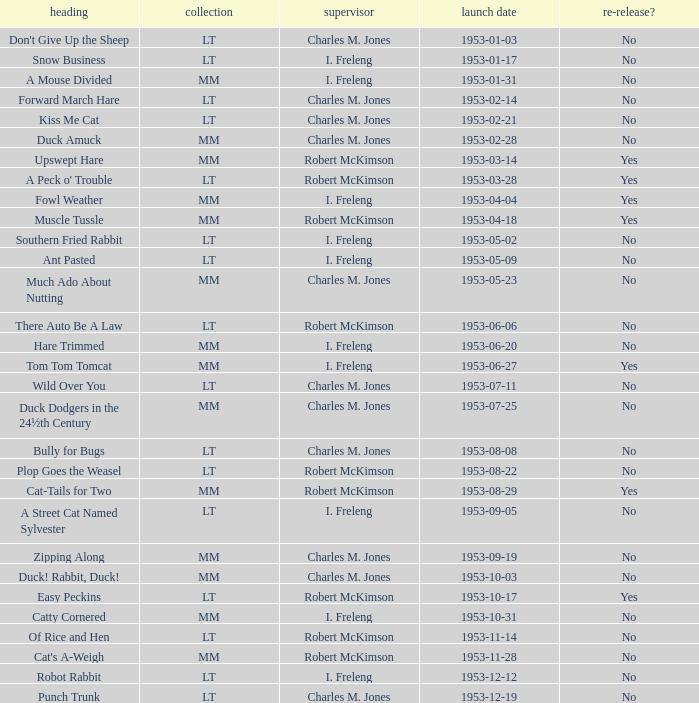What's the release date of Upswept Hare? 1953-03-14. 